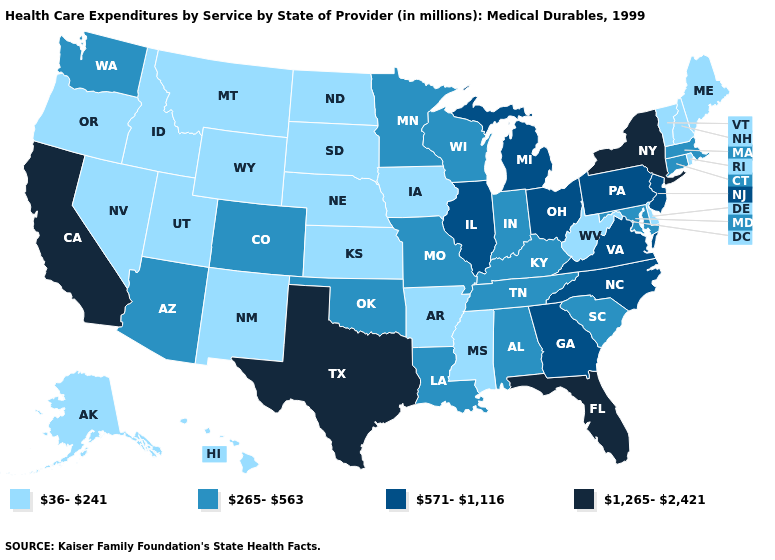Which states have the lowest value in the Northeast?
Short answer required. Maine, New Hampshire, Rhode Island, Vermont. Name the states that have a value in the range 265-563?
Short answer required. Alabama, Arizona, Colorado, Connecticut, Indiana, Kentucky, Louisiana, Maryland, Massachusetts, Minnesota, Missouri, Oklahoma, South Carolina, Tennessee, Washington, Wisconsin. Does Louisiana have a lower value than New York?
Answer briefly. Yes. How many symbols are there in the legend?
Write a very short answer. 4. Name the states that have a value in the range 265-563?
Answer briefly. Alabama, Arizona, Colorado, Connecticut, Indiana, Kentucky, Louisiana, Maryland, Massachusetts, Minnesota, Missouri, Oklahoma, South Carolina, Tennessee, Washington, Wisconsin. Is the legend a continuous bar?
Keep it brief. No. Does California have the lowest value in the West?
Short answer required. No. Name the states that have a value in the range 36-241?
Quick response, please. Alaska, Arkansas, Delaware, Hawaii, Idaho, Iowa, Kansas, Maine, Mississippi, Montana, Nebraska, Nevada, New Hampshire, New Mexico, North Dakota, Oregon, Rhode Island, South Dakota, Utah, Vermont, West Virginia, Wyoming. Which states have the lowest value in the South?
Answer briefly. Arkansas, Delaware, Mississippi, West Virginia. What is the value of Iowa?
Answer briefly. 36-241. Does New Jersey have the same value as North Carolina?
Quick response, please. Yes. Which states hav the highest value in the Northeast?
Keep it brief. New York. What is the value of North Carolina?
Give a very brief answer. 571-1,116. Among the states that border West Virginia , does Maryland have the highest value?
Quick response, please. No. 